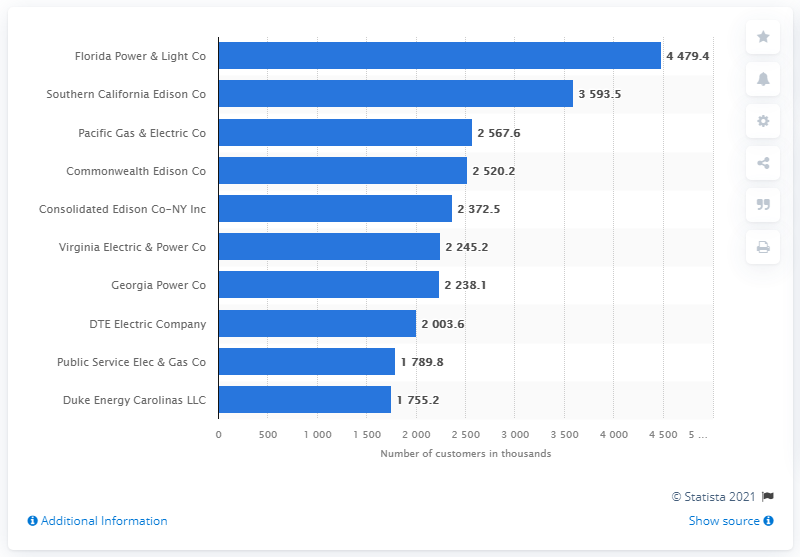Mention a couple of crucial points in this snapshot. According to data from 2019, the leading United States electric utility in terms of the number of residential customers was Florida Power & Light Company. 